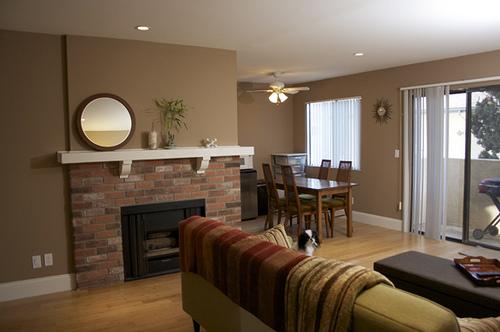What room is this picture taken in?
Quick response, please. Living room. Is the fireplace on?
Keep it brief. No. What is on in the room?
Write a very short answer. Light. Can you watch TV in this room?
Write a very short answer. No. 